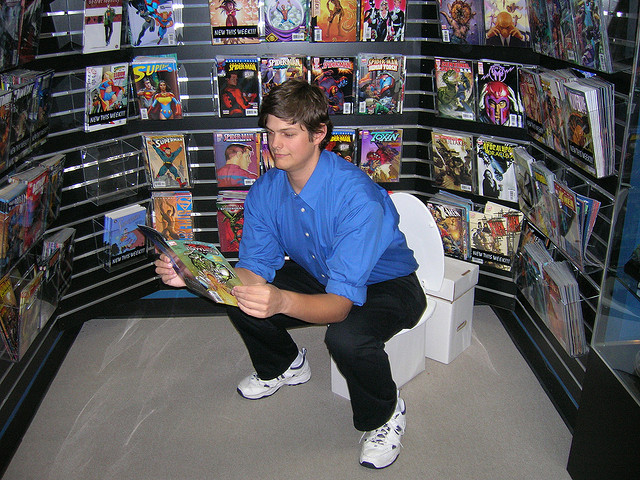Extract all visible text content from this image. SPIDER-MAN TOXIN 